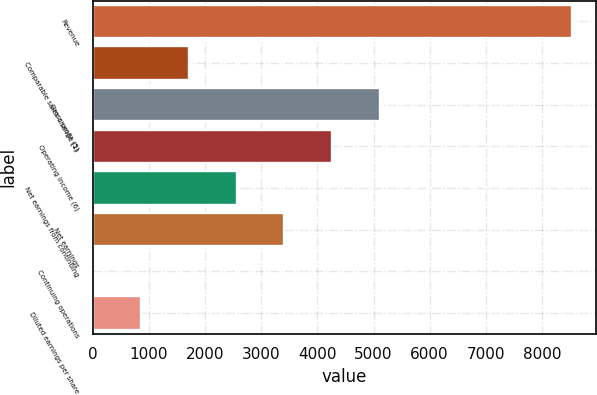Convert chart. <chart><loc_0><loc_0><loc_500><loc_500><bar_chart><fcel>Revenue<fcel>Comparable sales change (1)<fcel>Gross profit (5)<fcel>Operating income (6)<fcel>Net earnings from continuing<fcel>Net earnings<fcel>Continuing operations<fcel>Diluted earnings per share<nl><fcel>8533<fcel>1707.04<fcel>5120<fcel>4266.76<fcel>2560.28<fcel>3413.52<fcel>0.56<fcel>853.8<nl></chart> 